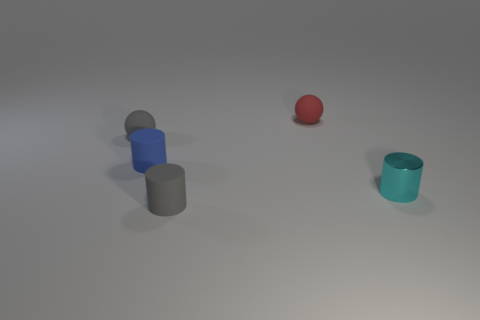Is there any other thing that has the same material as the cyan object?
Offer a terse response. No. Are there fewer small gray cylinders than gray matte things?
Provide a short and direct response. Yes. Are there any gray balls right of the metallic thing?
Your response must be concise. No. What shape is the matte object that is both on the right side of the blue rubber cylinder and behind the metallic thing?
Provide a succinct answer. Sphere. Are there any gray things of the same shape as the small red rubber object?
Offer a very short reply. Yes. There is a gray thing behind the cyan metallic thing; is its size the same as the thing on the right side of the red thing?
Provide a succinct answer. Yes. Are there more small gray rubber cylinders than big gray rubber balls?
Provide a succinct answer. Yes. How many tiny cyan cylinders have the same material as the red ball?
Your answer should be very brief. 0. Does the red matte object have the same shape as the small metal thing?
Offer a terse response. No. There is a object that is to the right of the rubber object that is behind the small matte ball left of the red ball; what is its size?
Make the answer very short. Small. 